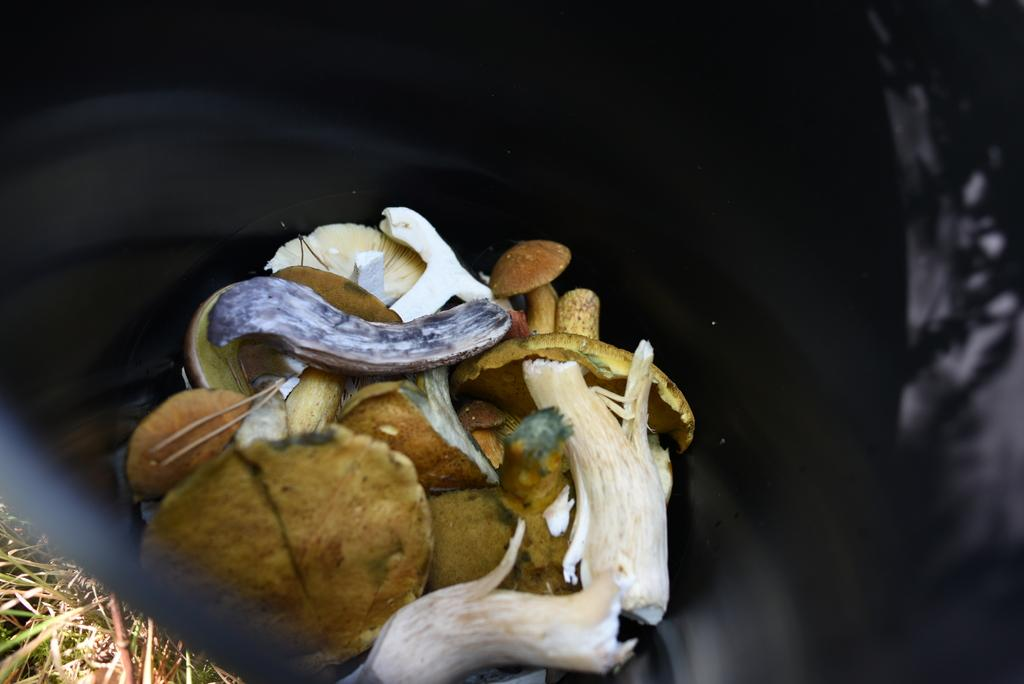What is the main object in the center of the image? There is a garbage bag in the center of the image. What is inside the garbage bag? The garbage bag contains waste materials. What type of natural environment can be seen in the image? There is grass in the bottom left side of the image. Where is the grandmother sitting in the image? There is no grandmother present in the image. What type of drawer can be seen in the image? There is no drawer present in the image. 